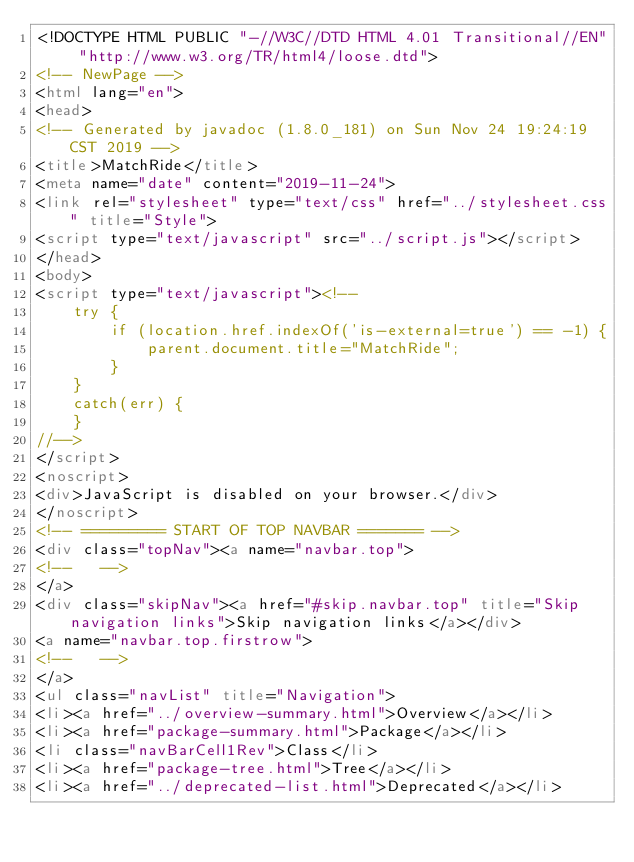<code> <loc_0><loc_0><loc_500><loc_500><_HTML_><!DOCTYPE HTML PUBLIC "-//W3C//DTD HTML 4.01 Transitional//EN" "http://www.w3.org/TR/html4/loose.dtd">
<!-- NewPage -->
<html lang="en">
<head>
<!-- Generated by javadoc (1.8.0_181) on Sun Nov 24 19:24:19 CST 2019 -->
<title>MatchRide</title>
<meta name="date" content="2019-11-24">
<link rel="stylesheet" type="text/css" href="../stylesheet.css" title="Style">
<script type="text/javascript" src="../script.js"></script>
</head>
<body>
<script type="text/javascript"><!--
    try {
        if (location.href.indexOf('is-external=true') == -1) {
            parent.document.title="MatchRide";
        }
    }
    catch(err) {
    }
//-->
</script>
<noscript>
<div>JavaScript is disabled on your browser.</div>
</noscript>
<!-- ========= START OF TOP NAVBAR ======= -->
<div class="topNav"><a name="navbar.top">
<!--   -->
</a>
<div class="skipNav"><a href="#skip.navbar.top" title="Skip navigation links">Skip navigation links</a></div>
<a name="navbar.top.firstrow">
<!--   -->
</a>
<ul class="navList" title="Navigation">
<li><a href="../overview-summary.html">Overview</a></li>
<li><a href="package-summary.html">Package</a></li>
<li class="navBarCell1Rev">Class</li>
<li><a href="package-tree.html">Tree</a></li>
<li><a href="../deprecated-list.html">Deprecated</a></li></code> 